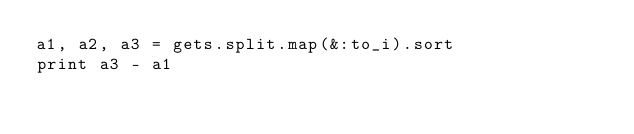Convert code to text. <code><loc_0><loc_0><loc_500><loc_500><_Ruby_>a1, a2, a3 = gets.split.map(&:to_i).sort
print a3 - a1
</code> 